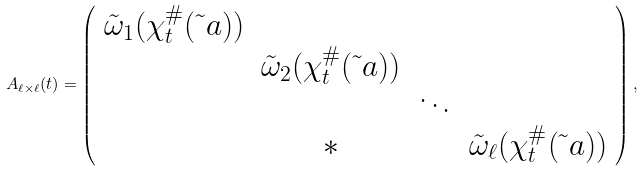Convert formula to latex. <formula><loc_0><loc_0><loc_500><loc_500>A _ { \ell \times \ell } ( t ) = \left ( \begin{array} { c c c c } \tilde { \omega } _ { 1 } ( \chi ^ { \# } _ { t } ( \tilde { \ } a ) ) & & & \\ & \tilde { \omega } _ { 2 } ( \chi ^ { \# } _ { t } ( \tilde { \ } a ) ) & & \\ & & \ddots & \\ & * & & \tilde { \omega } _ { \ell } ( \chi ^ { \# } _ { t } ( \tilde { \ } a ) ) \end{array} \right ) ,</formula> 